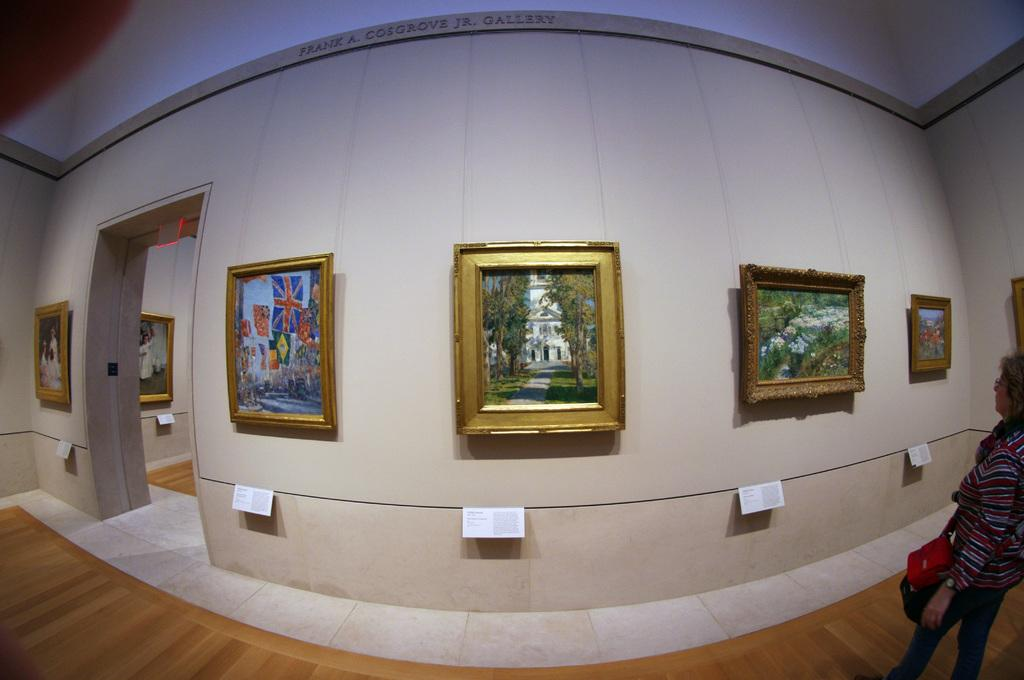What can be seen on the walls in the image? There are pictures on the walls in the image. Are there any additional details about the pictures? Yes, there are information cards under the pictures. Can you describe the person visible in the image? A person is visible in the image, and they are wearing a bag. What type of sound does the toad make in the image? There is no toad present in the image, so it is not possible to determine the sound it might make. 